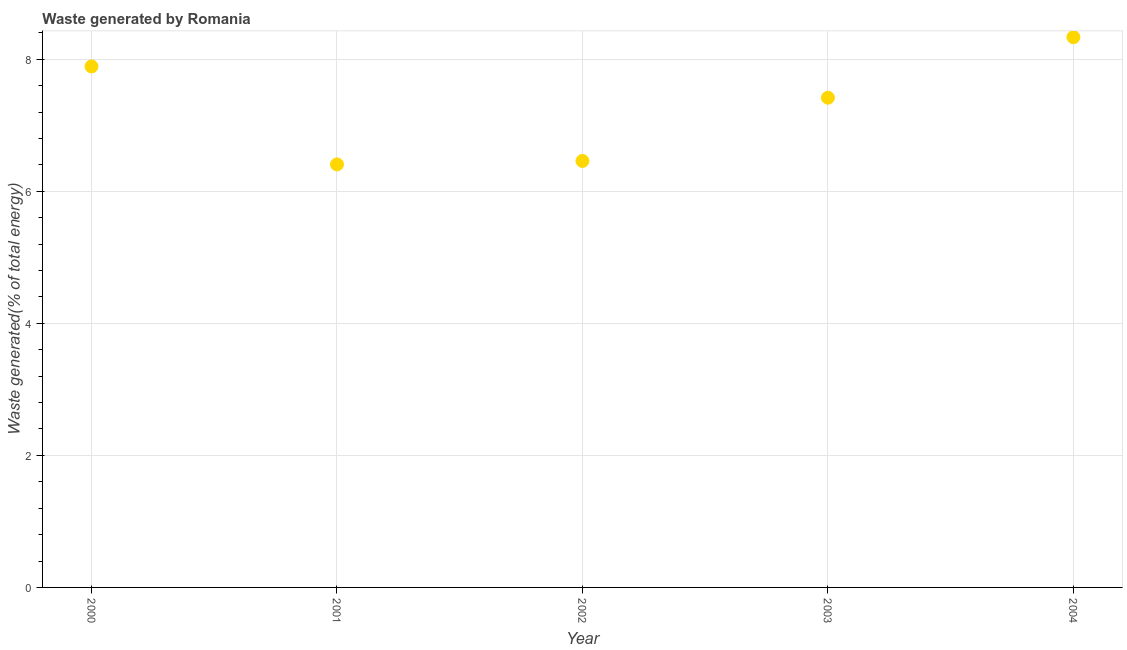What is the amount of waste generated in 2004?
Your answer should be compact. 8.33. Across all years, what is the maximum amount of waste generated?
Keep it short and to the point. 8.33. Across all years, what is the minimum amount of waste generated?
Your answer should be compact. 6.41. What is the sum of the amount of waste generated?
Provide a short and direct response. 36.51. What is the difference between the amount of waste generated in 2000 and 2002?
Provide a succinct answer. 1.43. What is the average amount of waste generated per year?
Your response must be concise. 7.3. What is the median amount of waste generated?
Make the answer very short. 7.42. Do a majority of the years between 2001 and 2000 (inclusive) have amount of waste generated greater than 6 %?
Provide a succinct answer. No. What is the ratio of the amount of waste generated in 2000 to that in 2003?
Give a very brief answer. 1.06. Is the amount of waste generated in 2002 less than that in 2003?
Offer a very short reply. Yes. What is the difference between the highest and the second highest amount of waste generated?
Offer a very short reply. 0.44. Is the sum of the amount of waste generated in 2002 and 2004 greater than the maximum amount of waste generated across all years?
Keep it short and to the point. Yes. What is the difference between the highest and the lowest amount of waste generated?
Your answer should be compact. 1.93. Does the amount of waste generated monotonically increase over the years?
Keep it short and to the point. No. How many dotlines are there?
Your response must be concise. 1. Are the values on the major ticks of Y-axis written in scientific E-notation?
Offer a terse response. No. Does the graph contain any zero values?
Provide a short and direct response. No. What is the title of the graph?
Your response must be concise. Waste generated by Romania. What is the label or title of the X-axis?
Provide a succinct answer. Year. What is the label or title of the Y-axis?
Give a very brief answer. Waste generated(% of total energy). What is the Waste generated(% of total energy) in 2000?
Provide a short and direct response. 7.89. What is the Waste generated(% of total energy) in 2001?
Your answer should be very brief. 6.41. What is the Waste generated(% of total energy) in 2002?
Ensure brevity in your answer.  6.46. What is the Waste generated(% of total energy) in 2003?
Your response must be concise. 7.42. What is the Waste generated(% of total energy) in 2004?
Your answer should be very brief. 8.33. What is the difference between the Waste generated(% of total energy) in 2000 and 2001?
Give a very brief answer. 1.48. What is the difference between the Waste generated(% of total energy) in 2000 and 2002?
Give a very brief answer. 1.43. What is the difference between the Waste generated(% of total energy) in 2000 and 2003?
Offer a very short reply. 0.47. What is the difference between the Waste generated(% of total energy) in 2000 and 2004?
Provide a succinct answer. -0.44. What is the difference between the Waste generated(% of total energy) in 2001 and 2002?
Offer a terse response. -0.05. What is the difference between the Waste generated(% of total energy) in 2001 and 2003?
Give a very brief answer. -1.01. What is the difference between the Waste generated(% of total energy) in 2001 and 2004?
Offer a very short reply. -1.93. What is the difference between the Waste generated(% of total energy) in 2002 and 2003?
Your answer should be compact. -0.96. What is the difference between the Waste generated(% of total energy) in 2002 and 2004?
Keep it short and to the point. -1.87. What is the difference between the Waste generated(% of total energy) in 2003 and 2004?
Your answer should be very brief. -0.92. What is the ratio of the Waste generated(% of total energy) in 2000 to that in 2001?
Your response must be concise. 1.23. What is the ratio of the Waste generated(% of total energy) in 2000 to that in 2002?
Ensure brevity in your answer.  1.22. What is the ratio of the Waste generated(% of total energy) in 2000 to that in 2003?
Provide a short and direct response. 1.06. What is the ratio of the Waste generated(% of total energy) in 2000 to that in 2004?
Give a very brief answer. 0.95. What is the ratio of the Waste generated(% of total energy) in 2001 to that in 2003?
Provide a succinct answer. 0.86. What is the ratio of the Waste generated(% of total energy) in 2001 to that in 2004?
Provide a short and direct response. 0.77. What is the ratio of the Waste generated(% of total energy) in 2002 to that in 2003?
Give a very brief answer. 0.87. What is the ratio of the Waste generated(% of total energy) in 2002 to that in 2004?
Make the answer very short. 0.78. What is the ratio of the Waste generated(% of total energy) in 2003 to that in 2004?
Keep it short and to the point. 0.89. 